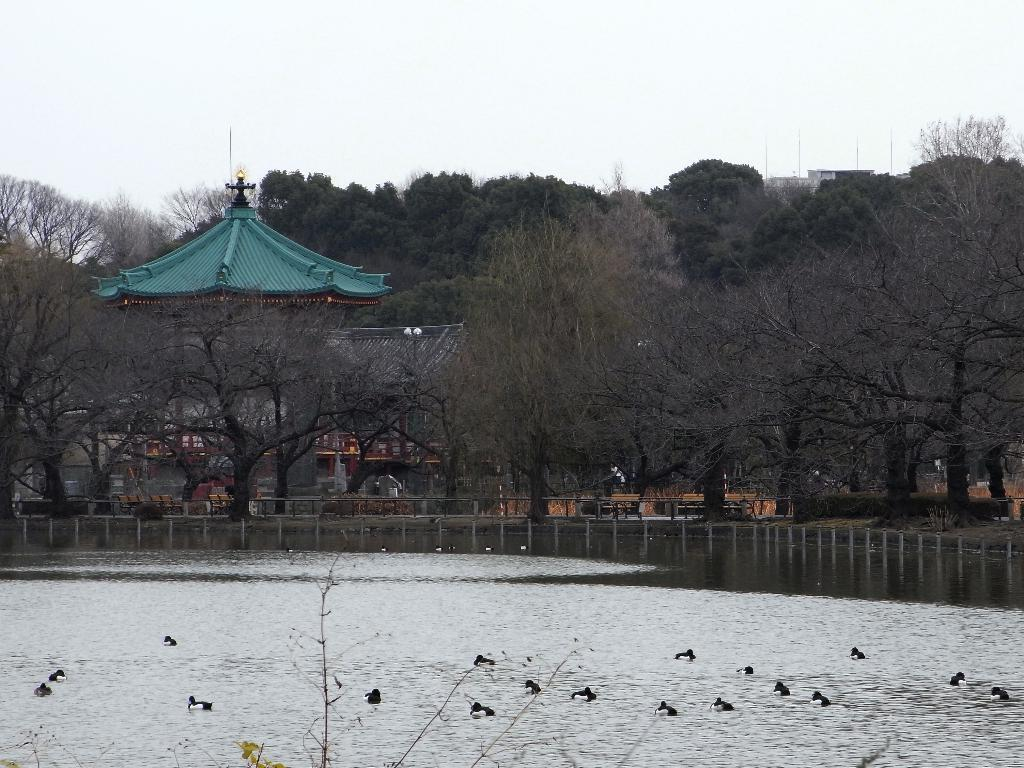What can be seen in the background of the image? In the background of the image, there is a sky, trees, and a building. What are the poles in the image used for? The purpose of the poles in the image is not specified, but they could be used for various purposes such as supporting wires or signs. What type of objects can be seen in the image? The objects in the image are not specified, but they could include natural elements like rocks or man-made items like benches or fences. Is there any water visible in the image? Yes, there is water visible in the image. What kind of animals are present in the image? There are birds in the image. What is visible at the bottom portion of the image? At the bottom portion of the image, there are branches visible. What is the teacher teaching in the image? There is no teacher or teaching activity present in the image. How many knees are visible in the image? There are no knees visible in the image. 